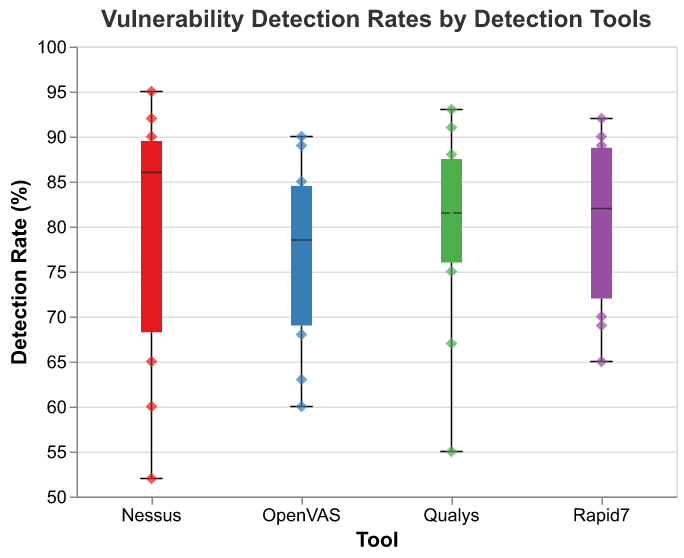What is the title of this graph? The title is displayed at the top of the graph.
Answer: Vulnerability Detection Rates by Detection Tools What is the y-axis measuring? The label on the y-axis indicates it measures percentages.
Answer: Detection Rate (%) Which tool has the widest range of detection rates? The box plot with the longest vertical extent indicates the widest range.
Answer: Nessus What's the median detection rate for Rapid7? The median line inside the Rapid7 box plot signifies the median detection rate.
Answer: 84 How many data points fall below the lower whisker for each tool? Refer to the scatter points that fall below the minimum box plot range (lower whisker) for each tool.
Answer: Nessus: 2, Qualys: 1, OpenVAS: 1, Rapid7: 0 Which tool has the highest single detection rate? Look for the highest scatter point on the y-axis.
Answer: Nessus What are the interquartile ranges (IQR) for Nessus and Qualys? The IQR is the box plot's height between the first and third quartiles. Compare these ranges for Nessus and Qualys. Nessus: Q3(90), Q1(65); Qualys: Q3(86), Q1(75)
Answer: Nessus: 25, Qualys: 11 Which detection tool has the lowest minimum detection rate? The lowest whisker or scatter point indicates the tool with the lowest minimum rate.
Answer: Nessus Which tool appears to have the most outliers below the box plot? Count the scatter points below the lower whisker for each tool.
Answer: Nessus Are there more overall data points for Nessus or Rapid7? Count the number of scatter points or box plot elements for each tool.
Answer: Nessus 